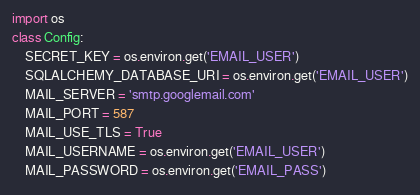Convert code to text. <code><loc_0><loc_0><loc_500><loc_500><_Python_>import os
class Config:
    SECRET_KEY = os.environ.get('EMAIL_USER')
    SQLALCHEMY_DATABASE_URI = os.environ.get('EMAIL_USER')
    MAIL_SERVER = 'smtp.googlemail.com'
    MAIL_PORT = 587
    MAIL_USE_TLS = True
    MAIL_USERNAME = os.environ.get('EMAIL_USER')
    MAIL_PASSWORD = os.environ.get('EMAIL_PASS')</code> 